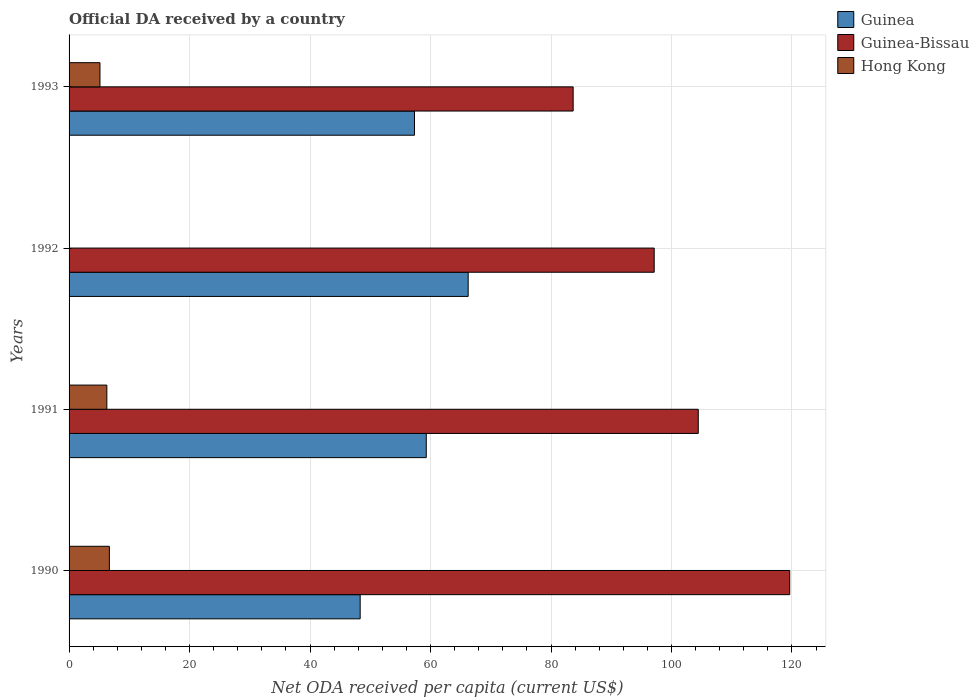How many different coloured bars are there?
Offer a very short reply. 3. Are the number of bars per tick equal to the number of legend labels?
Provide a succinct answer. No. How many bars are there on the 4th tick from the bottom?
Provide a succinct answer. 3. What is the label of the 4th group of bars from the top?
Your answer should be very brief. 1990. In how many cases, is the number of bars for a given year not equal to the number of legend labels?
Your answer should be compact. 1. What is the ODA received in in Guinea-Bissau in 1991?
Ensure brevity in your answer.  104.44. Across all years, what is the maximum ODA received in in Hong Kong?
Make the answer very short. 6.69. Across all years, what is the minimum ODA received in in Guinea-Bissau?
Offer a terse response. 83.68. In which year was the ODA received in in Hong Kong maximum?
Give a very brief answer. 1990. What is the total ODA received in in Guinea in the graph?
Provide a short and direct response. 231.2. What is the difference between the ODA received in in Guinea-Bissau in 1990 and that in 1992?
Your answer should be very brief. 22.5. What is the difference between the ODA received in in Guinea in 1992 and the ODA received in in Hong Kong in 1993?
Provide a succinct answer. 61.12. What is the average ODA received in in Guinea per year?
Offer a very short reply. 57.8. In the year 1990, what is the difference between the ODA received in in Guinea and ODA received in in Guinea-Bissau?
Keep it short and to the point. -71.3. What is the ratio of the ODA received in in Guinea-Bissau in 1991 to that in 1992?
Provide a short and direct response. 1.08. What is the difference between the highest and the second highest ODA received in in Guinea-Bissau?
Give a very brief answer. 15.18. What is the difference between the highest and the lowest ODA received in in Guinea?
Keep it short and to the point. 17.93. Is the sum of the ODA received in in Guinea-Bissau in 1991 and 1992 greater than the maximum ODA received in in Hong Kong across all years?
Your response must be concise. Yes. How many bars are there?
Your answer should be very brief. 11. What is the difference between two consecutive major ticks on the X-axis?
Offer a terse response. 20. Are the values on the major ticks of X-axis written in scientific E-notation?
Your response must be concise. No. Where does the legend appear in the graph?
Your answer should be very brief. Top right. How many legend labels are there?
Offer a terse response. 3. How are the legend labels stacked?
Your response must be concise. Vertical. What is the title of the graph?
Offer a terse response. Official DA received by a country. Does "United States" appear as one of the legend labels in the graph?
Ensure brevity in your answer.  No. What is the label or title of the X-axis?
Give a very brief answer. Net ODA received per capita (current US$). What is the label or title of the Y-axis?
Offer a very short reply. Years. What is the Net ODA received per capita (current US$) in Guinea in 1990?
Your answer should be very brief. 48.32. What is the Net ODA received per capita (current US$) in Guinea-Bissau in 1990?
Your answer should be very brief. 119.63. What is the Net ODA received per capita (current US$) of Hong Kong in 1990?
Your response must be concise. 6.69. What is the Net ODA received per capita (current US$) of Guinea in 1991?
Give a very brief answer. 59.29. What is the Net ODA received per capita (current US$) of Guinea-Bissau in 1991?
Provide a succinct answer. 104.44. What is the Net ODA received per capita (current US$) of Hong Kong in 1991?
Give a very brief answer. 6.27. What is the Net ODA received per capita (current US$) in Guinea in 1992?
Provide a short and direct response. 66.25. What is the Net ODA received per capita (current US$) in Guinea-Bissau in 1992?
Offer a very short reply. 97.13. What is the Net ODA received per capita (current US$) in Guinea in 1993?
Your answer should be very brief. 57.34. What is the Net ODA received per capita (current US$) in Guinea-Bissau in 1993?
Offer a terse response. 83.68. What is the Net ODA received per capita (current US$) in Hong Kong in 1993?
Offer a very short reply. 5.13. Across all years, what is the maximum Net ODA received per capita (current US$) of Guinea?
Your response must be concise. 66.25. Across all years, what is the maximum Net ODA received per capita (current US$) in Guinea-Bissau?
Your response must be concise. 119.63. Across all years, what is the maximum Net ODA received per capita (current US$) of Hong Kong?
Provide a succinct answer. 6.69. Across all years, what is the minimum Net ODA received per capita (current US$) in Guinea?
Keep it short and to the point. 48.32. Across all years, what is the minimum Net ODA received per capita (current US$) in Guinea-Bissau?
Your answer should be very brief. 83.68. Across all years, what is the minimum Net ODA received per capita (current US$) in Hong Kong?
Your response must be concise. 0. What is the total Net ODA received per capita (current US$) of Guinea in the graph?
Offer a terse response. 231.2. What is the total Net ODA received per capita (current US$) in Guinea-Bissau in the graph?
Make the answer very short. 404.88. What is the total Net ODA received per capita (current US$) of Hong Kong in the graph?
Provide a succinct answer. 18.09. What is the difference between the Net ODA received per capita (current US$) in Guinea in 1990 and that in 1991?
Your answer should be very brief. -10.97. What is the difference between the Net ODA received per capita (current US$) of Guinea-Bissau in 1990 and that in 1991?
Your answer should be very brief. 15.18. What is the difference between the Net ODA received per capita (current US$) in Hong Kong in 1990 and that in 1991?
Give a very brief answer. 0.42. What is the difference between the Net ODA received per capita (current US$) in Guinea in 1990 and that in 1992?
Your response must be concise. -17.93. What is the difference between the Net ODA received per capita (current US$) of Guinea-Bissau in 1990 and that in 1992?
Ensure brevity in your answer.  22.5. What is the difference between the Net ODA received per capita (current US$) in Guinea in 1990 and that in 1993?
Your response must be concise. -9.02. What is the difference between the Net ODA received per capita (current US$) of Guinea-Bissau in 1990 and that in 1993?
Make the answer very short. 35.95. What is the difference between the Net ODA received per capita (current US$) of Hong Kong in 1990 and that in 1993?
Ensure brevity in your answer.  1.56. What is the difference between the Net ODA received per capita (current US$) in Guinea in 1991 and that in 1992?
Give a very brief answer. -6.96. What is the difference between the Net ODA received per capita (current US$) of Guinea-Bissau in 1991 and that in 1992?
Your answer should be compact. 7.31. What is the difference between the Net ODA received per capita (current US$) in Guinea in 1991 and that in 1993?
Your answer should be compact. 1.96. What is the difference between the Net ODA received per capita (current US$) in Guinea-Bissau in 1991 and that in 1993?
Give a very brief answer. 20.77. What is the difference between the Net ODA received per capita (current US$) in Hong Kong in 1991 and that in 1993?
Provide a succinct answer. 1.14. What is the difference between the Net ODA received per capita (current US$) in Guinea in 1992 and that in 1993?
Offer a very short reply. 8.91. What is the difference between the Net ODA received per capita (current US$) in Guinea-Bissau in 1992 and that in 1993?
Make the answer very short. 13.45. What is the difference between the Net ODA received per capita (current US$) of Guinea in 1990 and the Net ODA received per capita (current US$) of Guinea-Bissau in 1991?
Offer a very short reply. -56.12. What is the difference between the Net ODA received per capita (current US$) in Guinea in 1990 and the Net ODA received per capita (current US$) in Hong Kong in 1991?
Give a very brief answer. 42.05. What is the difference between the Net ODA received per capita (current US$) of Guinea-Bissau in 1990 and the Net ODA received per capita (current US$) of Hong Kong in 1991?
Ensure brevity in your answer.  113.36. What is the difference between the Net ODA received per capita (current US$) in Guinea in 1990 and the Net ODA received per capita (current US$) in Guinea-Bissau in 1992?
Offer a very short reply. -48.81. What is the difference between the Net ODA received per capita (current US$) in Guinea in 1990 and the Net ODA received per capita (current US$) in Guinea-Bissau in 1993?
Ensure brevity in your answer.  -35.35. What is the difference between the Net ODA received per capita (current US$) in Guinea in 1990 and the Net ODA received per capita (current US$) in Hong Kong in 1993?
Offer a terse response. 43.19. What is the difference between the Net ODA received per capita (current US$) in Guinea-Bissau in 1990 and the Net ODA received per capita (current US$) in Hong Kong in 1993?
Your response must be concise. 114.5. What is the difference between the Net ODA received per capita (current US$) in Guinea in 1991 and the Net ODA received per capita (current US$) in Guinea-Bissau in 1992?
Give a very brief answer. -37.84. What is the difference between the Net ODA received per capita (current US$) in Guinea in 1991 and the Net ODA received per capita (current US$) in Guinea-Bissau in 1993?
Ensure brevity in your answer.  -24.38. What is the difference between the Net ODA received per capita (current US$) in Guinea in 1991 and the Net ODA received per capita (current US$) in Hong Kong in 1993?
Offer a very short reply. 54.16. What is the difference between the Net ODA received per capita (current US$) in Guinea-Bissau in 1991 and the Net ODA received per capita (current US$) in Hong Kong in 1993?
Ensure brevity in your answer.  99.31. What is the difference between the Net ODA received per capita (current US$) in Guinea in 1992 and the Net ODA received per capita (current US$) in Guinea-Bissau in 1993?
Your answer should be very brief. -17.43. What is the difference between the Net ODA received per capita (current US$) in Guinea in 1992 and the Net ODA received per capita (current US$) in Hong Kong in 1993?
Your answer should be very brief. 61.12. What is the difference between the Net ODA received per capita (current US$) in Guinea-Bissau in 1992 and the Net ODA received per capita (current US$) in Hong Kong in 1993?
Your answer should be very brief. 92. What is the average Net ODA received per capita (current US$) of Guinea per year?
Offer a very short reply. 57.8. What is the average Net ODA received per capita (current US$) in Guinea-Bissau per year?
Your response must be concise. 101.22. What is the average Net ODA received per capita (current US$) of Hong Kong per year?
Give a very brief answer. 4.52. In the year 1990, what is the difference between the Net ODA received per capita (current US$) of Guinea and Net ODA received per capita (current US$) of Guinea-Bissau?
Provide a short and direct response. -71.3. In the year 1990, what is the difference between the Net ODA received per capita (current US$) of Guinea and Net ODA received per capita (current US$) of Hong Kong?
Keep it short and to the point. 41.63. In the year 1990, what is the difference between the Net ODA received per capita (current US$) in Guinea-Bissau and Net ODA received per capita (current US$) in Hong Kong?
Offer a very short reply. 112.94. In the year 1991, what is the difference between the Net ODA received per capita (current US$) in Guinea and Net ODA received per capita (current US$) in Guinea-Bissau?
Provide a succinct answer. -45.15. In the year 1991, what is the difference between the Net ODA received per capita (current US$) of Guinea and Net ODA received per capita (current US$) of Hong Kong?
Provide a succinct answer. 53.02. In the year 1991, what is the difference between the Net ODA received per capita (current US$) of Guinea-Bissau and Net ODA received per capita (current US$) of Hong Kong?
Offer a very short reply. 98.17. In the year 1992, what is the difference between the Net ODA received per capita (current US$) of Guinea and Net ODA received per capita (current US$) of Guinea-Bissau?
Make the answer very short. -30.88. In the year 1993, what is the difference between the Net ODA received per capita (current US$) in Guinea and Net ODA received per capita (current US$) in Guinea-Bissau?
Provide a succinct answer. -26.34. In the year 1993, what is the difference between the Net ODA received per capita (current US$) in Guinea and Net ODA received per capita (current US$) in Hong Kong?
Provide a succinct answer. 52.21. In the year 1993, what is the difference between the Net ODA received per capita (current US$) in Guinea-Bissau and Net ODA received per capita (current US$) in Hong Kong?
Ensure brevity in your answer.  78.55. What is the ratio of the Net ODA received per capita (current US$) in Guinea in 1990 to that in 1991?
Offer a very short reply. 0.81. What is the ratio of the Net ODA received per capita (current US$) of Guinea-Bissau in 1990 to that in 1991?
Your response must be concise. 1.15. What is the ratio of the Net ODA received per capita (current US$) of Hong Kong in 1990 to that in 1991?
Your response must be concise. 1.07. What is the ratio of the Net ODA received per capita (current US$) of Guinea in 1990 to that in 1992?
Make the answer very short. 0.73. What is the ratio of the Net ODA received per capita (current US$) of Guinea-Bissau in 1990 to that in 1992?
Your answer should be compact. 1.23. What is the ratio of the Net ODA received per capita (current US$) of Guinea in 1990 to that in 1993?
Give a very brief answer. 0.84. What is the ratio of the Net ODA received per capita (current US$) in Guinea-Bissau in 1990 to that in 1993?
Give a very brief answer. 1.43. What is the ratio of the Net ODA received per capita (current US$) of Hong Kong in 1990 to that in 1993?
Provide a succinct answer. 1.3. What is the ratio of the Net ODA received per capita (current US$) in Guinea in 1991 to that in 1992?
Provide a short and direct response. 0.9. What is the ratio of the Net ODA received per capita (current US$) of Guinea-Bissau in 1991 to that in 1992?
Offer a terse response. 1.08. What is the ratio of the Net ODA received per capita (current US$) of Guinea in 1991 to that in 1993?
Provide a short and direct response. 1.03. What is the ratio of the Net ODA received per capita (current US$) in Guinea-Bissau in 1991 to that in 1993?
Your response must be concise. 1.25. What is the ratio of the Net ODA received per capita (current US$) of Hong Kong in 1991 to that in 1993?
Your answer should be compact. 1.22. What is the ratio of the Net ODA received per capita (current US$) in Guinea in 1992 to that in 1993?
Provide a short and direct response. 1.16. What is the ratio of the Net ODA received per capita (current US$) in Guinea-Bissau in 1992 to that in 1993?
Offer a very short reply. 1.16. What is the difference between the highest and the second highest Net ODA received per capita (current US$) in Guinea?
Give a very brief answer. 6.96. What is the difference between the highest and the second highest Net ODA received per capita (current US$) in Guinea-Bissau?
Ensure brevity in your answer.  15.18. What is the difference between the highest and the second highest Net ODA received per capita (current US$) in Hong Kong?
Make the answer very short. 0.42. What is the difference between the highest and the lowest Net ODA received per capita (current US$) in Guinea?
Make the answer very short. 17.93. What is the difference between the highest and the lowest Net ODA received per capita (current US$) of Guinea-Bissau?
Ensure brevity in your answer.  35.95. What is the difference between the highest and the lowest Net ODA received per capita (current US$) in Hong Kong?
Offer a terse response. 6.69. 